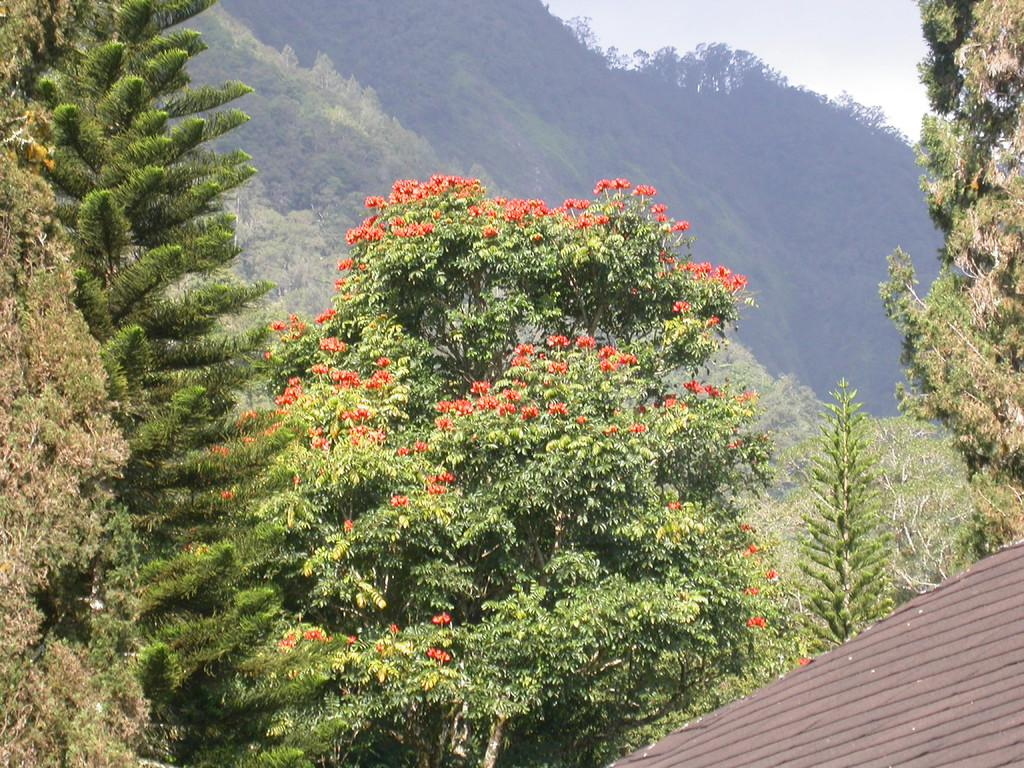What is located on the right side of the image? There is a roof of a building on the right side of the image. What type of natural elements can be seen in the image? There are trees and hills in the image. What type of grape is being used as a cannon in the image? There is no grape or cannon present in the image. 